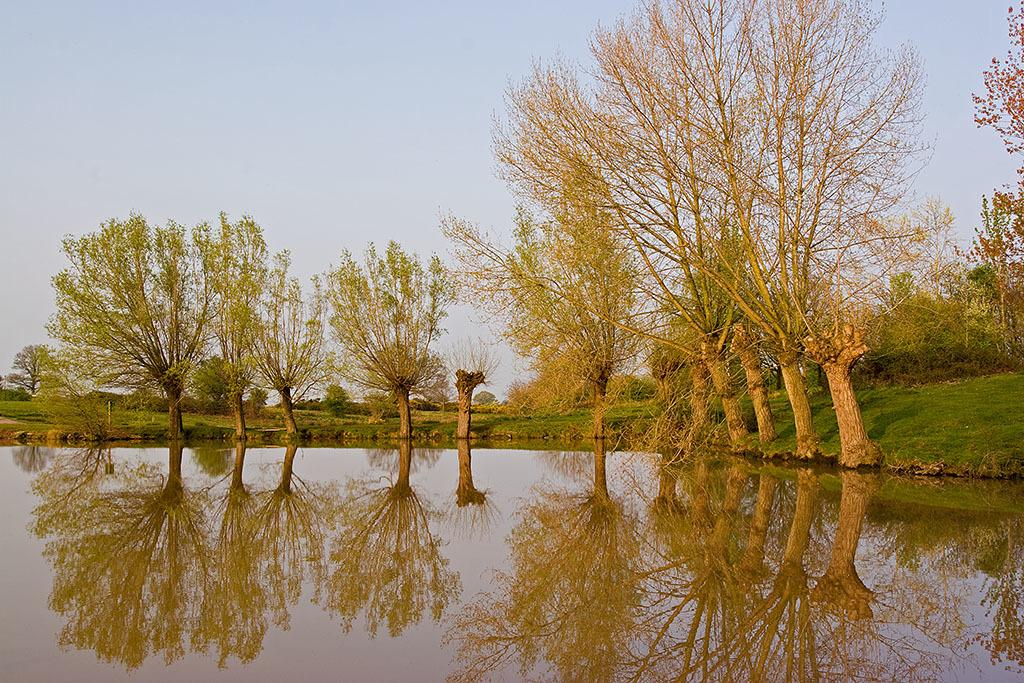What type of vegetation can be seen in the image? There are trees, grass, and plants in the image. What natural element is visible at the bottom of the image? There is water at the bottom of the image. What can be seen in the background of the image? The sky is visible in the background of the image. What type of cracker is floating on the water in the image? There is no cracker present in the image; it only features trees, grass, plants, water, and the sky. How many cattle can be seen grazing in the grass in the image? There are no cattle present in the image; it only features trees, grass, plants, water, and the sky. 